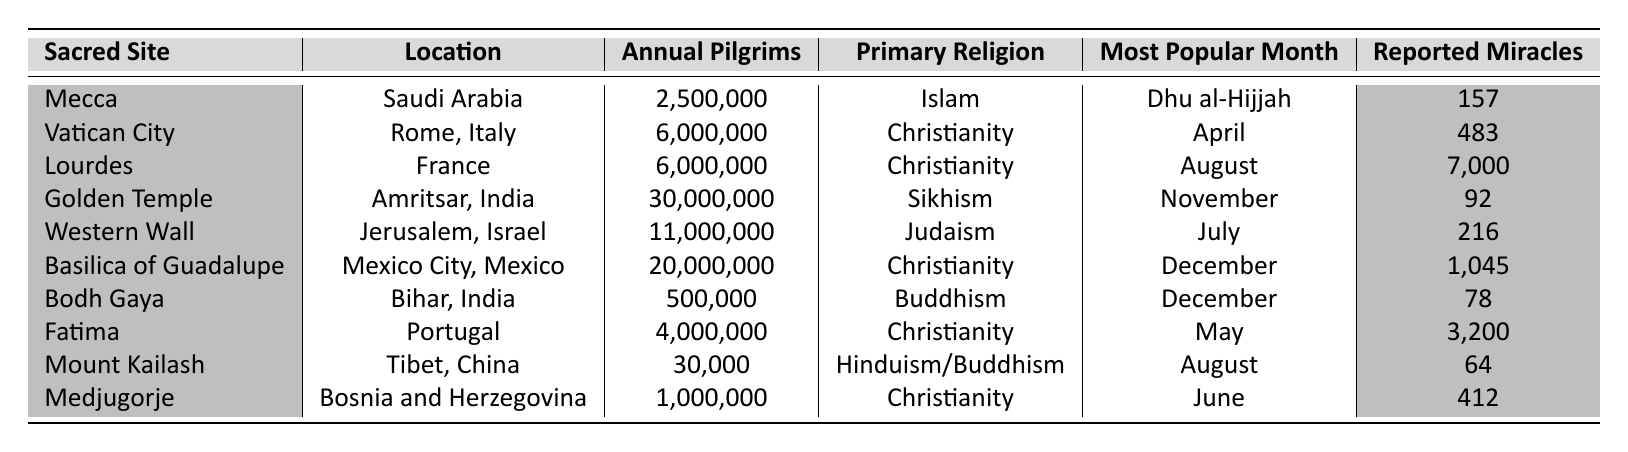What is the most popular month for pilgrims visiting Lourdes? The table indicates that the most popular month for Lourdes in France is August, which is listed under the "Most Popular Month" column.
Answer: August How many reported miracles occurred at the Basilica of Guadalupe? According to the table, the Basilica of Guadalupe in Mexico City has reported 1,045 miracles, as shown in the "Reported Miracles" column.
Answer: 1,045 Which sacred site has the fewest annual pilgrims? By examining the "Annual Pilgrims" column, Mount Kailash, located in Tibet, China, has the fewest annual pilgrims at 30,000.
Answer: 30,000 What is the total number of reported miracles across all sacred sites? To find the total, sum the reported miracles: 157 + 483 + 7,000 + 92 + 216 + 1,045 + 78 + 3,200 + 64 + 412 = 12,777.
Answer: 12,777 Is the primary religion at the Golden Temple Sikhism? The table shows that the primary religion for the Golden Temple in Amritsar, India, is Sikhism, confirming the fact is true.
Answer: Yes Which three sacred sites have the highest annual pilgrims? The three sites with the highest annual pilgrims are the Golden Temple (30,000,000), Basilica of Guadalupe (20,000,000), and Vatican City (6,000,000).
Answer: Golden Temple, Basilica of Guadalupe, Vatican City For which sacred site does the most popular month occur in December? The table indicates that both the Basilica of Guadalupe and Bodh Gaya have December as their most popular month for pilgrims.
Answer: Basilica of Guadalupe, Bodh Gaya What is the average number of reported miracles for the sacred sites? Calculate the average by summing the reported miracles (12,777) and dividing by the number of sites (10): 12,777 / 10 = 1,277.7.
Answer: 1,277.7 Does the reported number of miracles at Lourdes exceed 1,000? The table indicates that Lourdes has reported 7,000 miracles, which is greater than 1,000, confirming the fact is true.
Answer: Yes Which sacred site has the highest number of annual pilgrims, and what is that number? According to the table, the Golden Temple in Amritsar, India, has the highest number of annual pilgrims at 30,000,000.
Answer: Golden Temple, 30,000,000 